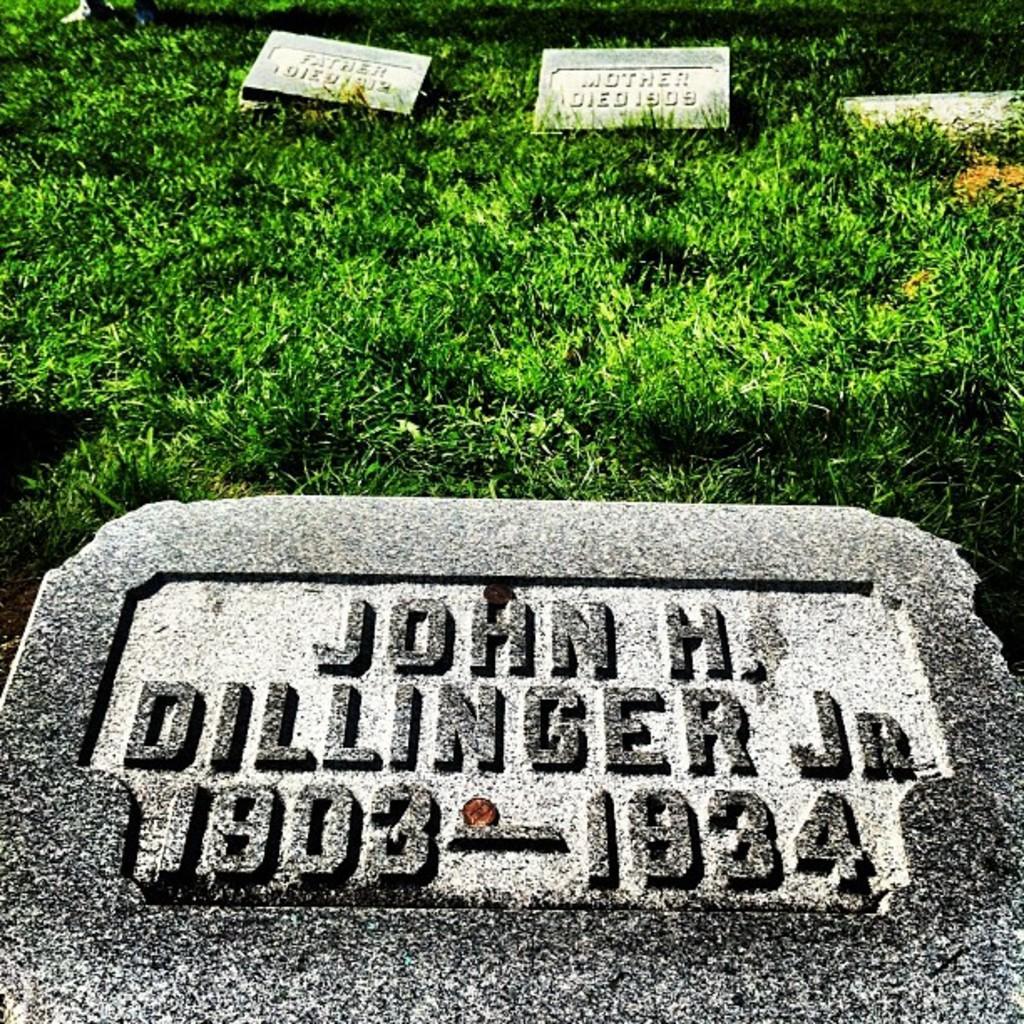How would you summarize this image in a sentence or two? In this picture I can see memorial stones on the grass. 